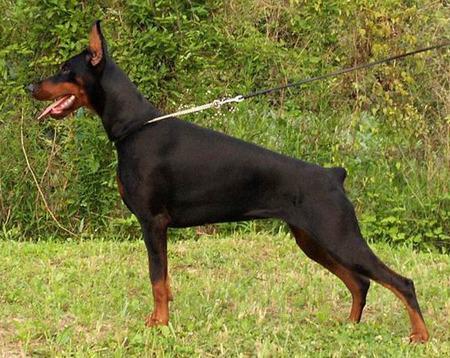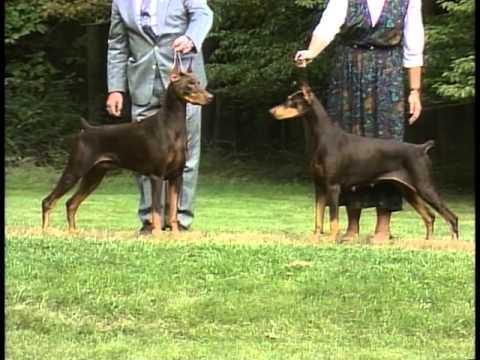The first image is the image on the left, the second image is the image on the right. Examine the images to the left and right. Is the description "At least one doberman has its tongue out." accurate? Answer yes or no. Yes. The first image is the image on the left, the second image is the image on the right. For the images shown, is this caption "In one image, there are two dogs facing each other." true? Answer yes or no. Yes. 